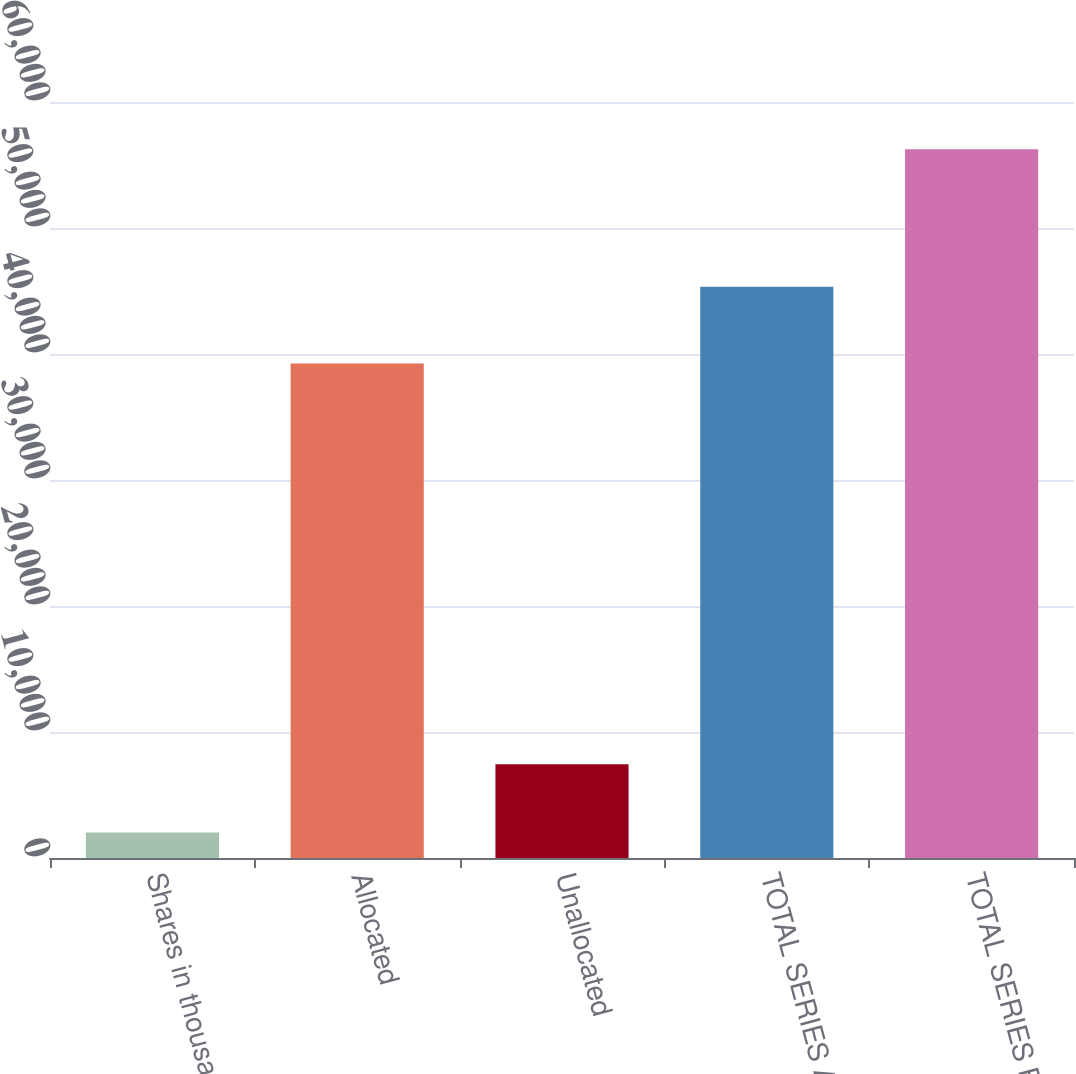Convert chart. <chart><loc_0><loc_0><loc_500><loc_500><bar_chart><fcel>Shares in thousands<fcel>Allocated<fcel>Unallocated<fcel>TOTAL SERIES A<fcel>TOTAL SERIES B<nl><fcel>2016<fcel>39241<fcel>7438.8<fcel>45336<fcel>56244<nl></chart> 